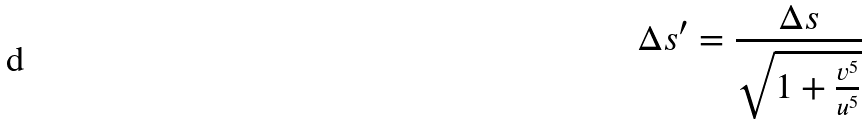Convert formula to latex. <formula><loc_0><loc_0><loc_500><loc_500>\Delta s ^ { \prime } = \frac { \Delta s } { \sqrt { 1 + \frac { v ^ { 5 } } { u ^ { 5 } } } }</formula> 